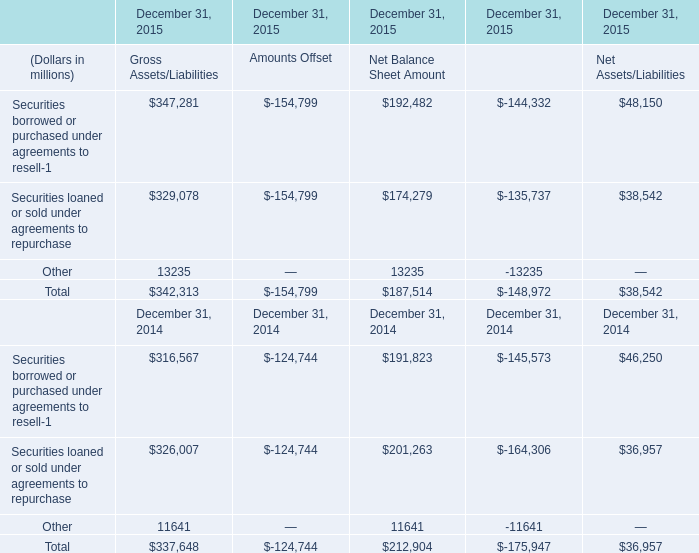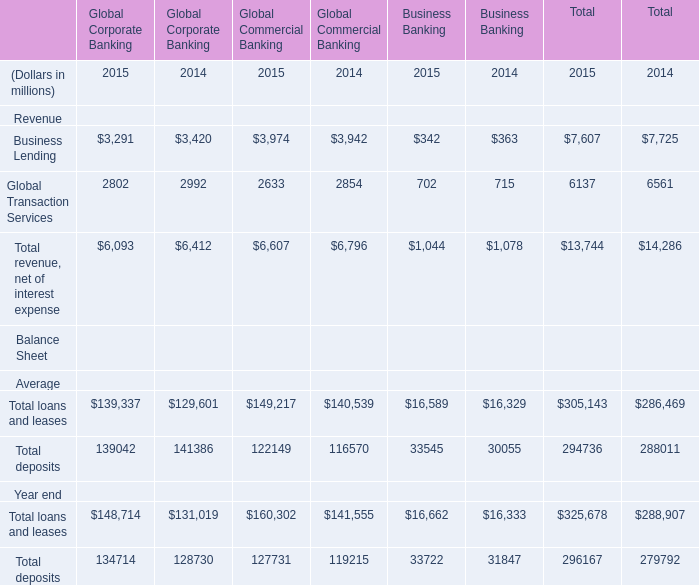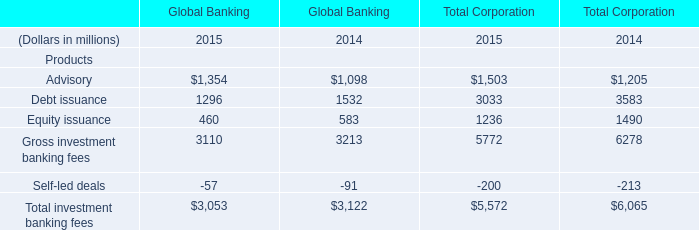Which year is Total loans and leases the most for Global Corporate Banking? 
Answer: 2015. 